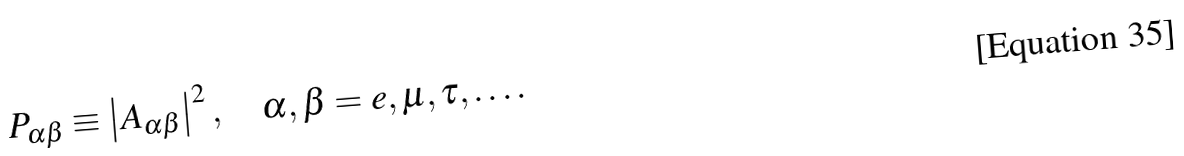<formula> <loc_0><loc_0><loc_500><loc_500>P _ { \alpha \beta } \equiv \left | A _ { \alpha \beta } \right | ^ { 2 } , \quad \alpha , \beta = e , \mu , \tau , \dots .</formula> 